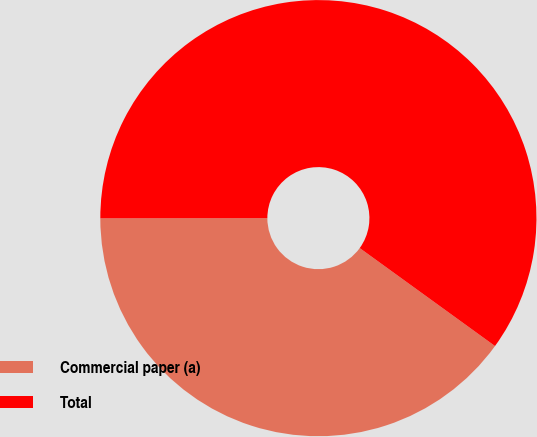<chart> <loc_0><loc_0><loc_500><loc_500><pie_chart><fcel>Commercial paper (a)<fcel>Total<nl><fcel>40.01%<fcel>59.99%<nl></chart> 